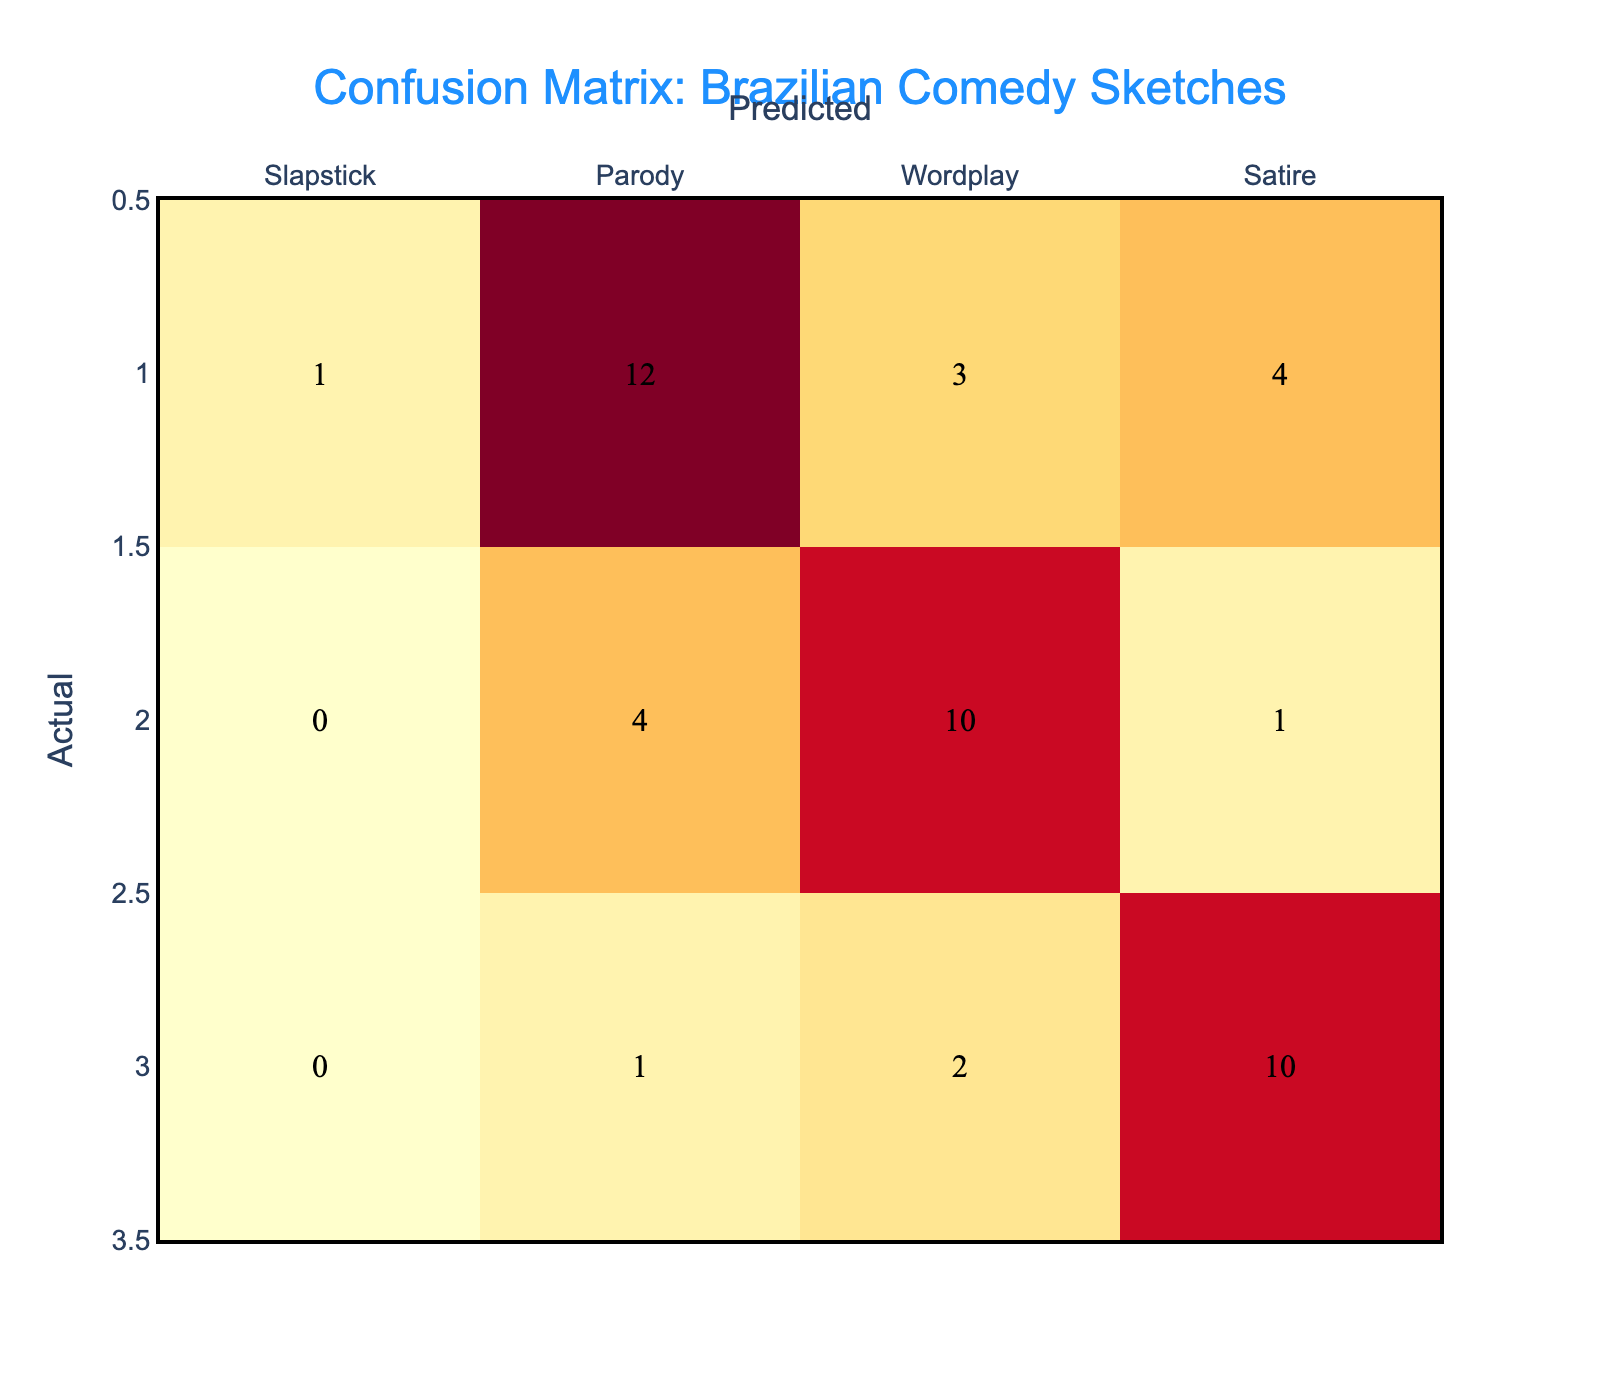What is the number of sketches classified as slapstick humor? Referring to the row labeled 'Slapstick', the total number of sketches classified as slapstick humor is 15.
Answer: 15 How many sketches were wrongly predicted as parody when the actual humor was slapstick? Looking at the 'Slapstick' row, there are 2 sketches that were predicted as parody instead of slapstick.
Answer: 2 What is the total number of sketches that belong to the wordplay category? By adding the values in the 'Wordplay' row: 0 (slapstick) + 4 (parody) + 10 (wordplay) + 1 (satire) = 15.
Answer: 15 Is the number of sketches actual classified as satire higher than those predicted as wordplay? The actual number of sketches classified as satire is 13 (0 + 1 + 2 + 10), while the predicted as wordplay is 16 (1 + 3 + 10 + 2). So, the assertion is false.
Answer: No What percentage of predictions for wordplay sketches were correct? In the 'Wordplay' row, there are 10 correctly predicted (true positives) out of a total of 15 actual wordplay sketches. Therefore, (10/15) × 100 = 66.67%.
Answer: 66.67% How many total sketches were predicted to be satire across all actual categories? To find this, we sum the 'Satire' column: 0 (slapstick) + 4 (parody) + 1 (wordplay) + 10 (satire) = 15.
Answer: 15 Which humor type had the highest count of correct predictions? The highest number of correct predictions is for slapstick, with 15 true positives noted in that row.
Answer: Slapstick What is the total number of comedy sketches incorrectly classified across all categories? Totaling the incorrect classifications: (2 from slapstick predicted as parody) + (1 from parody as slapstick) + (4 from parody as satire) + (4 from wordplay as parody) + (1 from wordplay as satire) + (1 from satire as parody) + (2 from satire as wordplay) = 15 incorrect classifications.
Answer: 15 